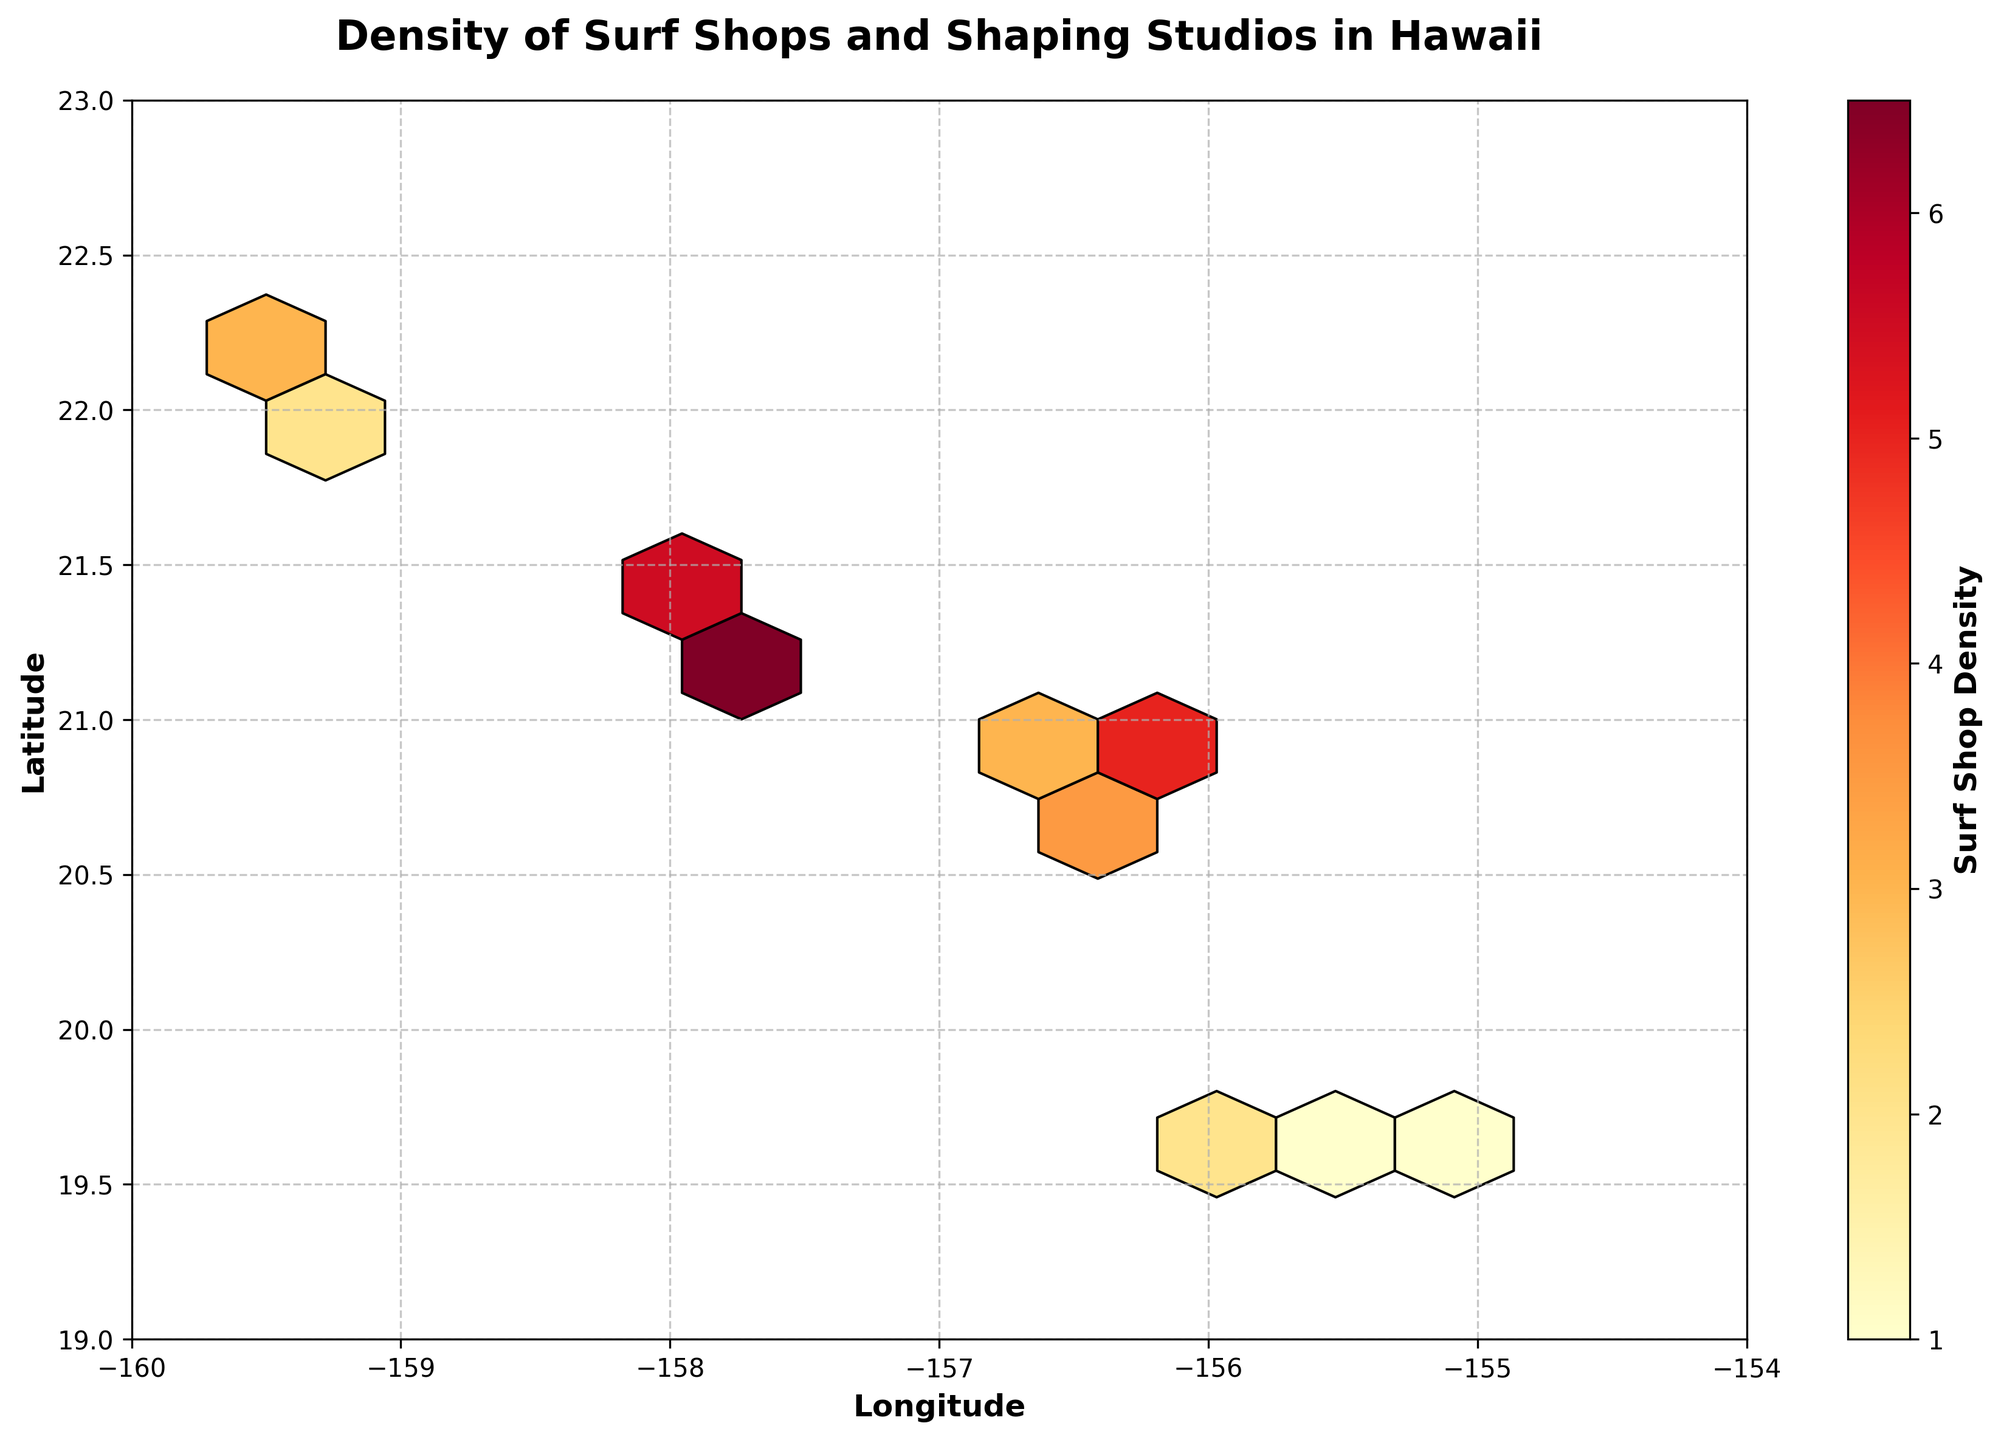What is the title of the plot? The title of the plot is usually displayed at the top, giving a clear description of what the figure represents. In this case, it highlights what the plot is about.
Answer: Density of Surf Shops and Shaping Studios in Hawaii What do the colors on the hexbin plot represent? The color of the hexagons represents the density of surf shops and shaping studios, where a color gradient from yellow to red indicates increasing density.
Answer: Surf shop density Which areas appear to have the highest density of surf shops and shaping studios? The hexagons with the darkest red colors indicate the highest density of surf shops and shaping studios. These are likely clustered around Honolulu on the island of Oahu.
Answer: Honolulu area What are the ranges of the latitude and longitude axes on the plot? The latitude ranges from 19 to 23 degrees, and the longitude ranges from -160 to -154 degrees. This can be observed from the axis markings.
Answer: Latitude: 19-23, Longitude: -160 to -154 What is the density value represented by the color bar's dark red color? The color bar (legend) next to the hexbin plot shows the density values corresponding to each color. The dark red typically represents the highest density value.
Answer: Highest density value (precise number depends on color bar inspection) Is there a region with low surf shop and shaping studio density? If so, where? Hexagons with lighter colors, towards yellow, indicate lower density. These are observed in regions such as the Big Island and Kauai.
Answer: Big Island and Kauai How does the density of surf shops and shaping studios compare between Oahu and Maui? By comparing the hexagon colors between these islands, Oahu shows more dark red hexagons indicating higher densities, while Maui shows lighter colors, suggesting lower densities.
Answer: Oahu has higher density than Maui How many unique density values are displayed on the color bar? By visually inspecting the color bar, one can count the distinct color segments or ticks that represent unique density values.
Answer: Varies based on the plot, typically around 5-7 What does the grid layout signify on the plot? The grid layout, formed by the hexbin, helps in segmenting the geographical area to visually represent the density of surf shops and shaping studios per segment.
Answer: Segmentation of geographical area by density Is there a noticeable clustering of data points? If so, around which area? A noticeable clustering of data points would be visible where many hexagons are dark red, indicating a high density of surf shops and shaping studios. This clustering is noticed around Honolulu on Oahu.
Answer: Around Honolulu on Oahu 